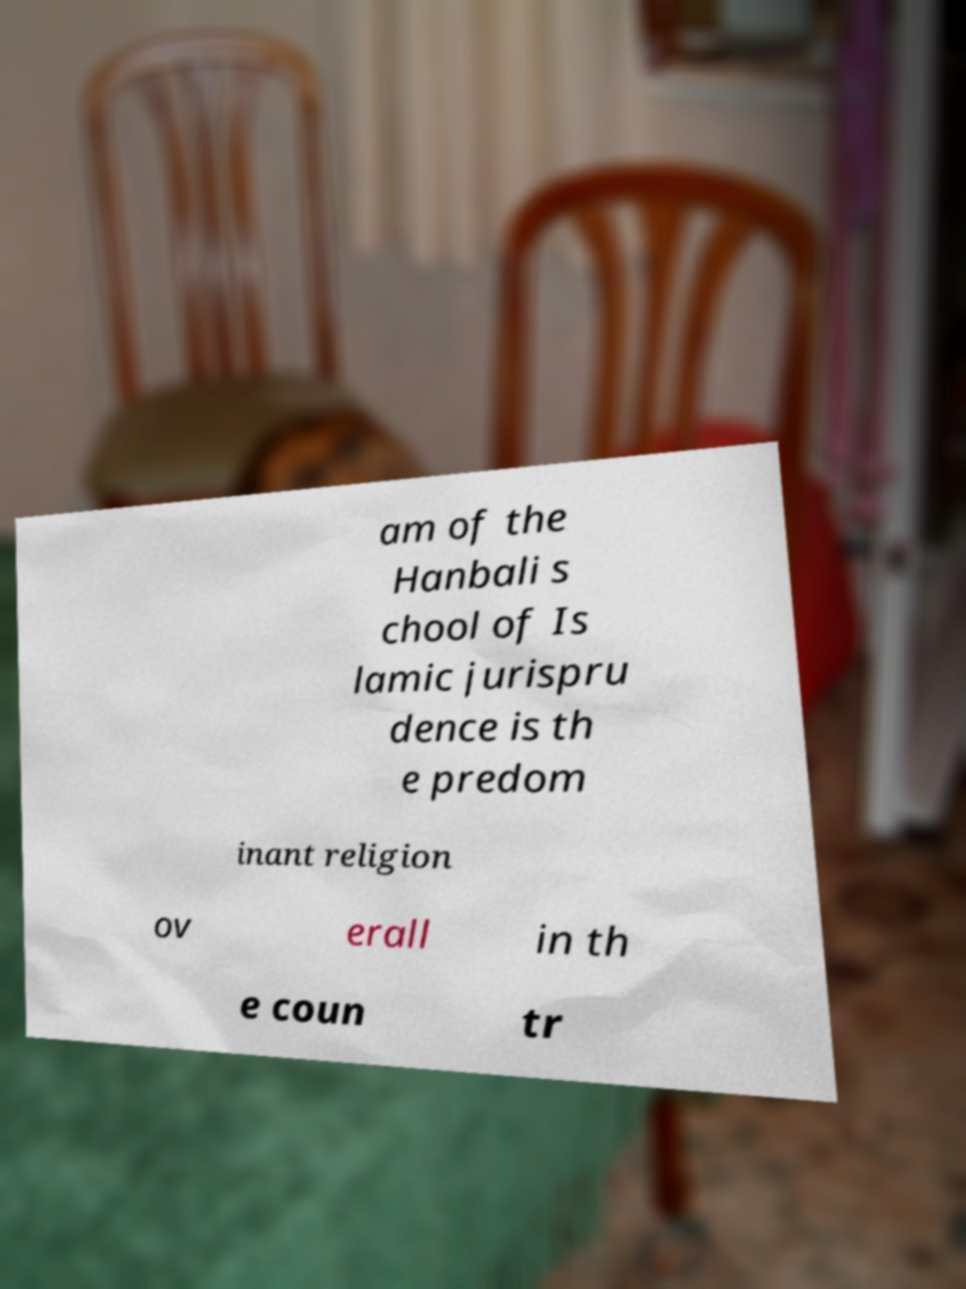Could you extract and type out the text from this image? am of the Hanbali s chool of Is lamic jurispru dence is th e predom inant religion ov erall in th e coun tr 